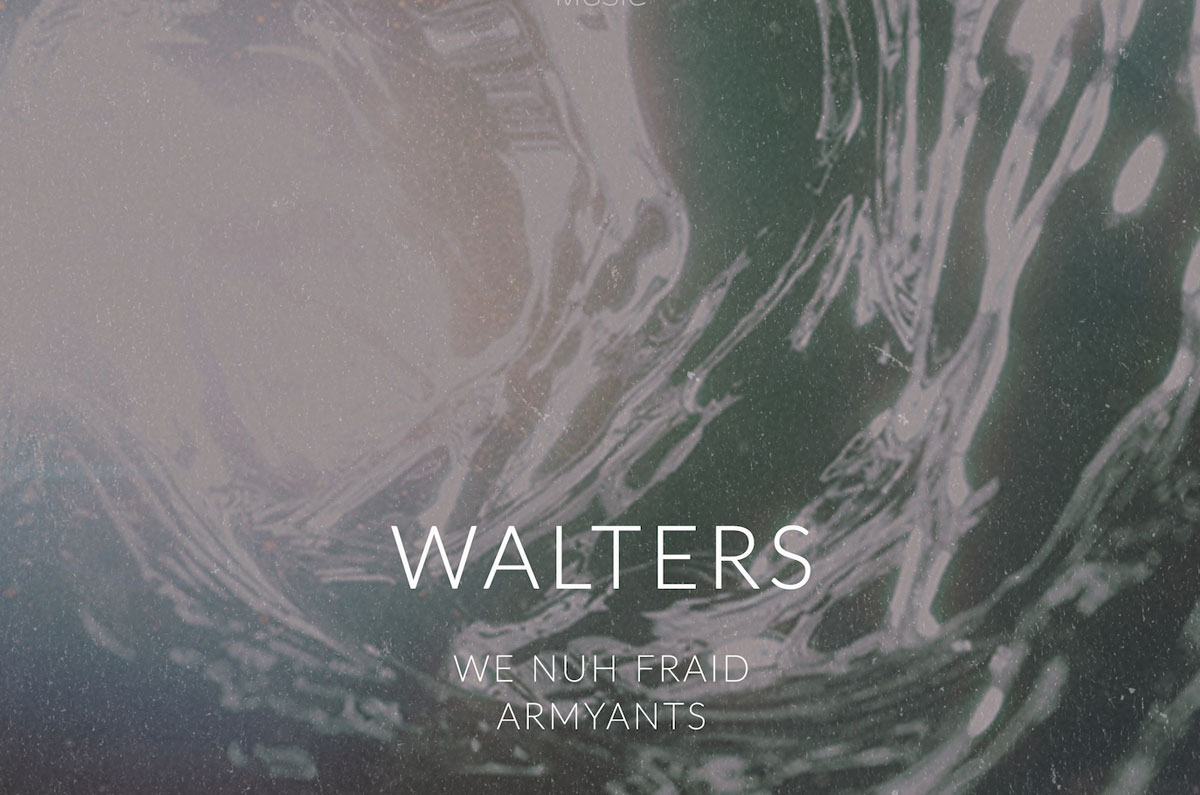Considering the varying text sizes and the stylized background, what artistic technique does the image most likely employ to draw the viewer's attention to the central message, and how does the technique achieve its effect? The image employs a hierarchical typographic technique to emphasize its central message. By utilizing different font sizes, the design establishes a clear visual hierarchy. The largest text, 'WALTERS,' instantly captures the viewer's attention as the main subject or title. The subsequent smaller texts, 'WE NUH FRAID' and 'ARMYANTS,' provide supporting information while ensuring that the focus remains on the central title. Moreover, the marbled background, with its contrasting yet harmonious colors, enhances the white text's legibility and visibility, making the entire composition visually engaging without overwhelming the viewer. 